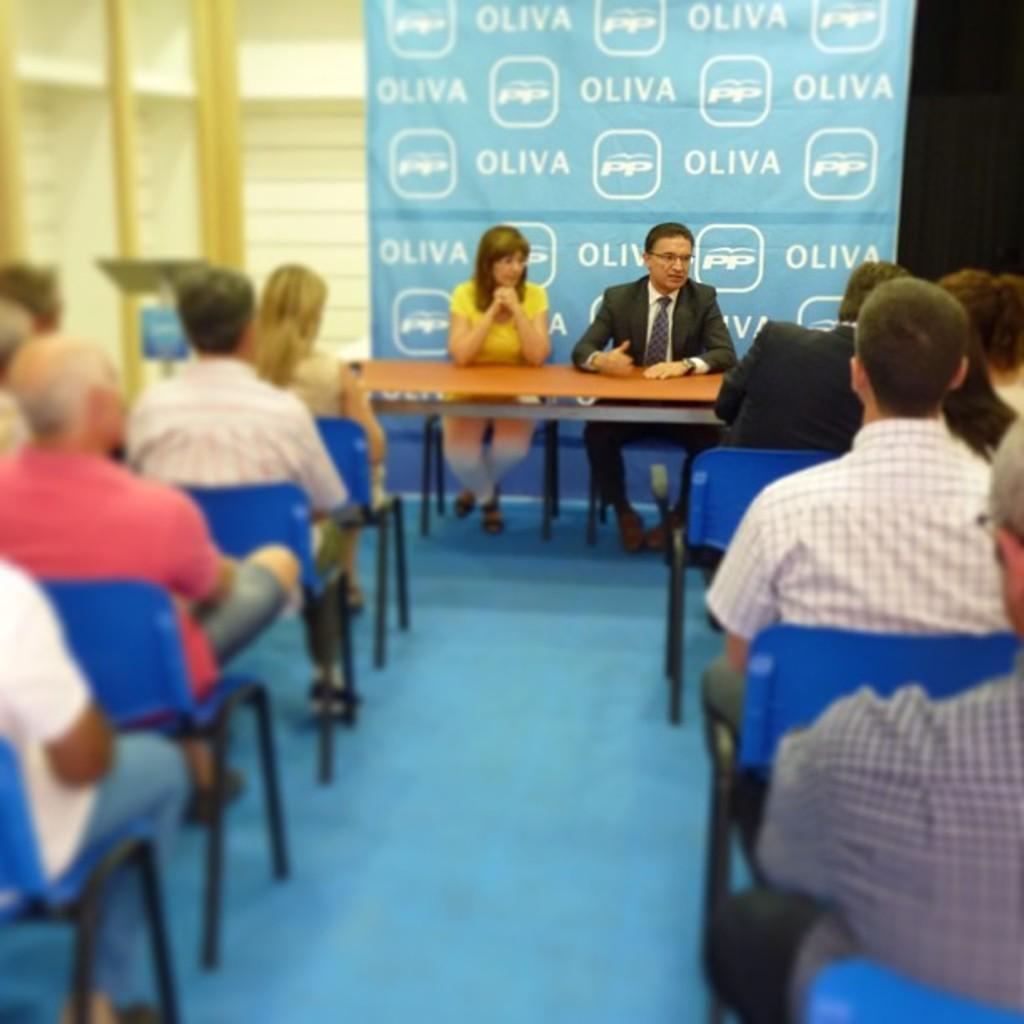How would you summarize this image in a sentence or two? In this picture we can see a man and a woman sitting on chairs in front of a table. On the background we can see a hoarding. Here at the right and left side of the picture we can see few persons sitting on a chairs. This is a floor. This is a podium. 